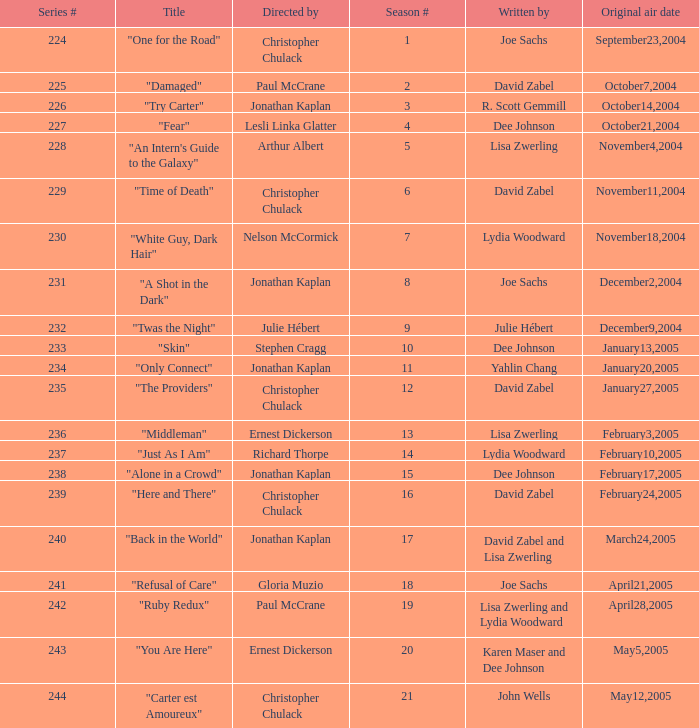Can you give me this table as a dict? {'header': ['Series #', 'Title', 'Directed by', 'Season #', 'Written by', 'Original air date'], 'rows': [['224', '"One for the Road"', 'Christopher Chulack', '1', 'Joe Sachs', 'September23,2004'], ['225', '"Damaged"', 'Paul McCrane', '2', 'David Zabel', 'October7,2004'], ['226', '"Try Carter"', 'Jonathan Kaplan', '3', 'R. Scott Gemmill', 'October14,2004'], ['227', '"Fear"', 'Lesli Linka Glatter', '4', 'Dee Johnson', 'October21,2004'], ['228', '"An Intern\'s Guide to the Galaxy"', 'Arthur Albert', '5', 'Lisa Zwerling', 'November4,2004'], ['229', '"Time of Death"', 'Christopher Chulack', '6', 'David Zabel', 'November11,2004'], ['230', '"White Guy, Dark Hair"', 'Nelson McCormick', '7', 'Lydia Woodward', 'November18,2004'], ['231', '"A Shot in the Dark"', 'Jonathan Kaplan', '8', 'Joe Sachs', 'December2,2004'], ['232', '"Twas the Night"', 'Julie Hébert', '9', 'Julie Hébert', 'December9,2004'], ['233', '"Skin"', 'Stephen Cragg', '10', 'Dee Johnson', 'January13,2005'], ['234', '"Only Connect"', 'Jonathan Kaplan', '11', 'Yahlin Chang', 'January20,2005'], ['235', '"The Providers"', 'Christopher Chulack', '12', 'David Zabel', 'January27,2005'], ['236', '"Middleman"', 'Ernest Dickerson', '13', 'Lisa Zwerling', 'February3,2005'], ['237', '"Just As I Am"', 'Richard Thorpe', '14', 'Lydia Woodward', 'February10,2005'], ['238', '"Alone in a Crowd"', 'Jonathan Kaplan', '15', 'Dee Johnson', 'February17,2005'], ['239', '"Here and There"', 'Christopher Chulack', '16', 'David Zabel', 'February24,2005'], ['240', '"Back in the World"', 'Jonathan Kaplan', '17', 'David Zabel and Lisa Zwerling', 'March24,2005'], ['241', '"Refusal of Care"', 'Gloria Muzio', '18', 'Joe Sachs', 'April21,2005'], ['242', '"Ruby Redux"', 'Paul McCrane', '19', 'Lisa Zwerling and Lydia Woodward', 'April28,2005'], ['243', '"You Are Here"', 'Ernest Dickerson', '20', 'Karen Maser and Dee Johnson', 'May5,2005'], ['244', '"Carter est Amoureux"', 'Christopher Chulack', '21', 'John Wells', 'May12,2005']]} Name the title that was written by r. scott gemmill "Try Carter". 